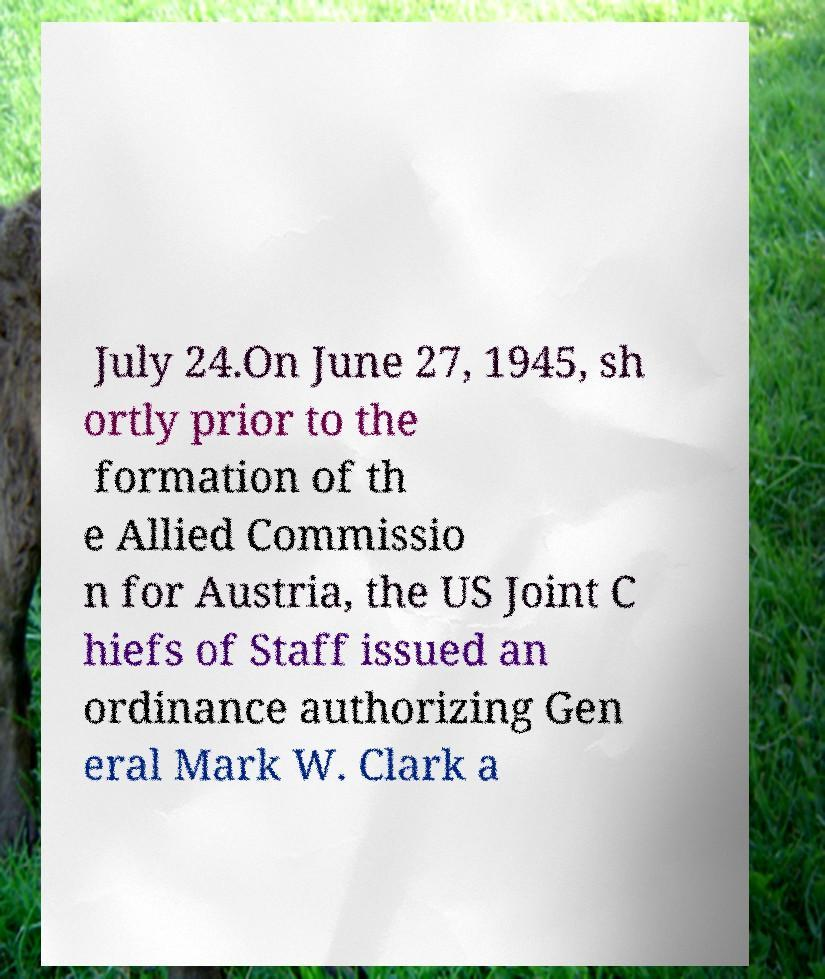Can you read and provide the text displayed in the image?This photo seems to have some interesting text. Can you extract and type it out for me? July 24.On June 27, 1945, sh ortly prior to the formation of th e Allied Commissio n for Austria, the US Joint C hiefs of Staff issued an ordinance authorizing Gen eral Mark W. Clark a 